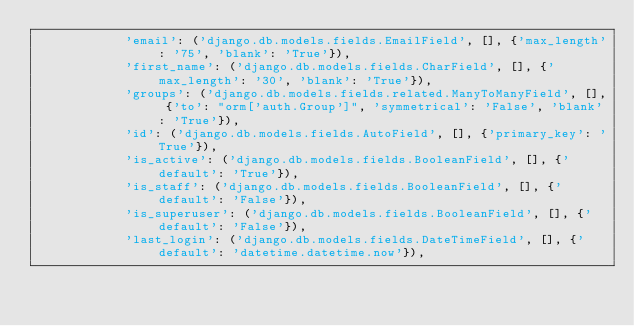Convert code to text. <code><loc_0><loc_0><loc_500><loc_500><_Python_>            'email': ('django.db.models.fields.EmailField', [], {'max_length': '75', 'blank': 'True'}),
            'first_name': ('django.db.models.fields.CharField', [], {'max_length': '30', 'blank': 'True'}),
            'groups': ('django.db.models.fields.related.ManyToManyField', [], {'to': "orm['auth.Group']", 'symmetrical': 'False', 'blank': 'True'}),
            'id': ('django.db.models.fields.AutoField', [], {'primary_key': 'True'}),
            'is_active': ('django.db.models.fields.BooleanField', [], {'default': 'True'}),
            'is_staff': ('django.db.models.fields.BooleanField', [], {'default': 'False'}),
            'is_superuser': ('django.db.models.fields.BooleanField', [], {'default': 'False'}),
            'last_login': ('django.db.models.fields.DateTimeField', [], {'default': 'datetime.datetime.now'}),</code> 